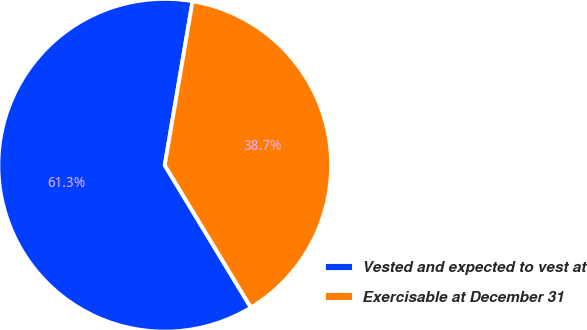Convert chart to OTSL. <chart><loc_0><loc_0><loc_500><loc_500><pie_chart><fcel>Vested and expected to vest at<fcel>Exercisable at December 31<nl><fcel>61.34%<fcel>38.66%<nl></chart> 